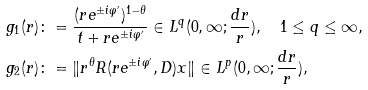Convert formula to latex. <formula><loc_0><loc_0><loc_500><loc_500>g _ { 1 } ( r ) & \colon = \frac { ( r e ^ { \pm i \varphi ^ { \prime } } ) ^ { 1 - \theta } } { t + r e ^ { \pm i \varphi ^ { \prime } } } \in L ^ { q } ( 0 , \infty ; \frac { d r } { r } ) , \quad 1 \leq q \leq \infty , \\ g _ { 2 } ( r ) & \colon = \| r ^ { \theta } R ( r e ^ { \pm i \varphi ^ { \prime } } , D ) x \| \in L ^ { p } ( 0 , \infty ; \frac { d r } { r } ) ,</formula> 